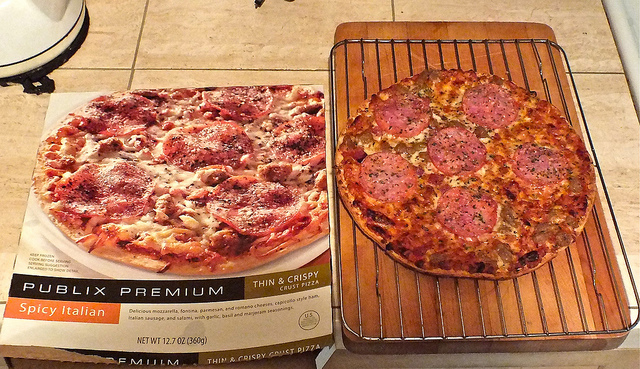Please transcribe the text information in this image. PUBLIX PREMIUM Spicy italian THIN PIZZA CRUST CRISPY &amp; crispy FMULM THIN 127 NET 